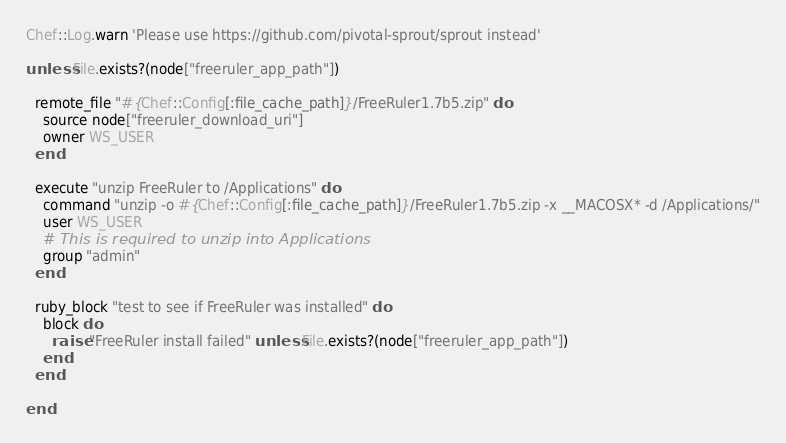<code> <loc_0><loc_0><loc_500><loc_500><_Ruby_>Chef::Log.warn 'Please use https://github.com/pivotal-sprout/sprout instead'

unless File.exists?(node["freeruler_app_path"])

  remote_file "#{Chef::Config[:file_cache_path]}/FreeRuler1.7b5.zip" do
    source node["freeruler_download_uri"]
    owner WS_USER
  end

  execute "unzip FreeRuler to /Applications" do
    command "unzip -o #{Chef::Config[:file_cache_path]}/FreeRuler1.7b5.zip -x __MACOSX* -d /Applications/"
    user WS_USER
    # This is required to unzip into Applications
    group "admin"
  end

  ruby_block "test to see if FreeRuler was installed" do
    block do
      raise "FreeRuler install failed" unless File.exists?(node["freeruler_app_path"])
    end
  end

end
</code> 